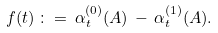Convert formula to latex. <formula><loc_0><loc_0><loc_500><loc_500>f ( t ) \, \colon = \, \alpha _ { t } ^ { ( 0 ) } ( A ) \, - \, \alpha _ { t } ^ { ( 1 ) } ( A ) .</formula> 